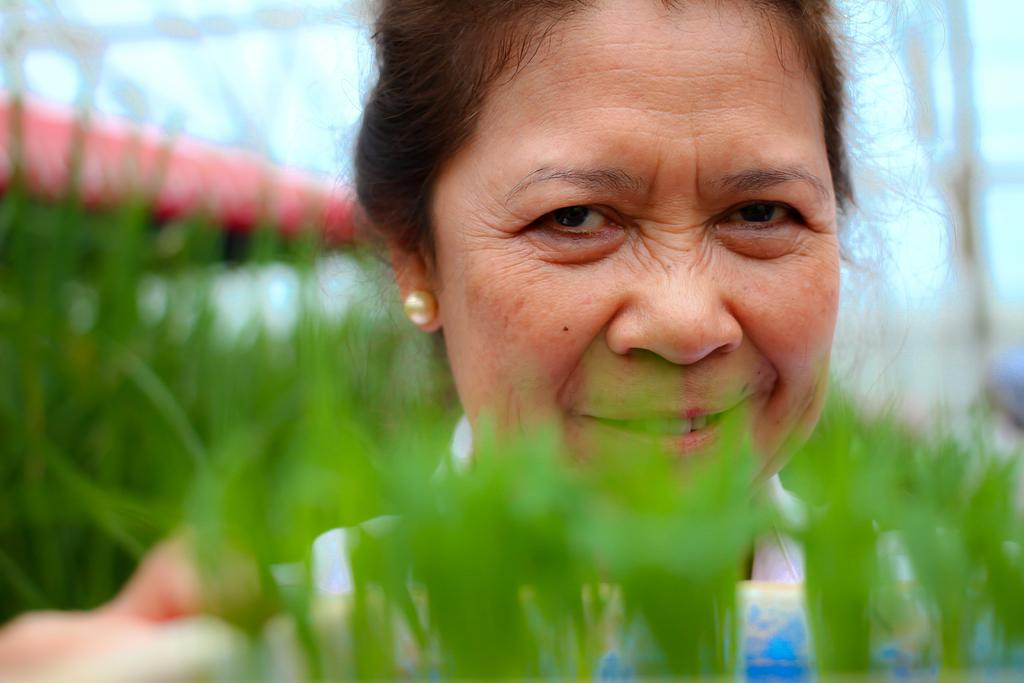What is located near the plants in the image? There is an object located near the plants in the image. Can you describe the woman in the background? The woman in the background is smiling. What else can be seen in the background of the image? There are plants and a roof visible in the background. What is visible above the roof in the image? The sky is visible in the background. What type of war is depicted in the image? There is no depiction of war in the image; it features plants, an object, and a woman in the background. Can you tell me how many people are swimming in the image? There is no swimming or water activity present in the image. 